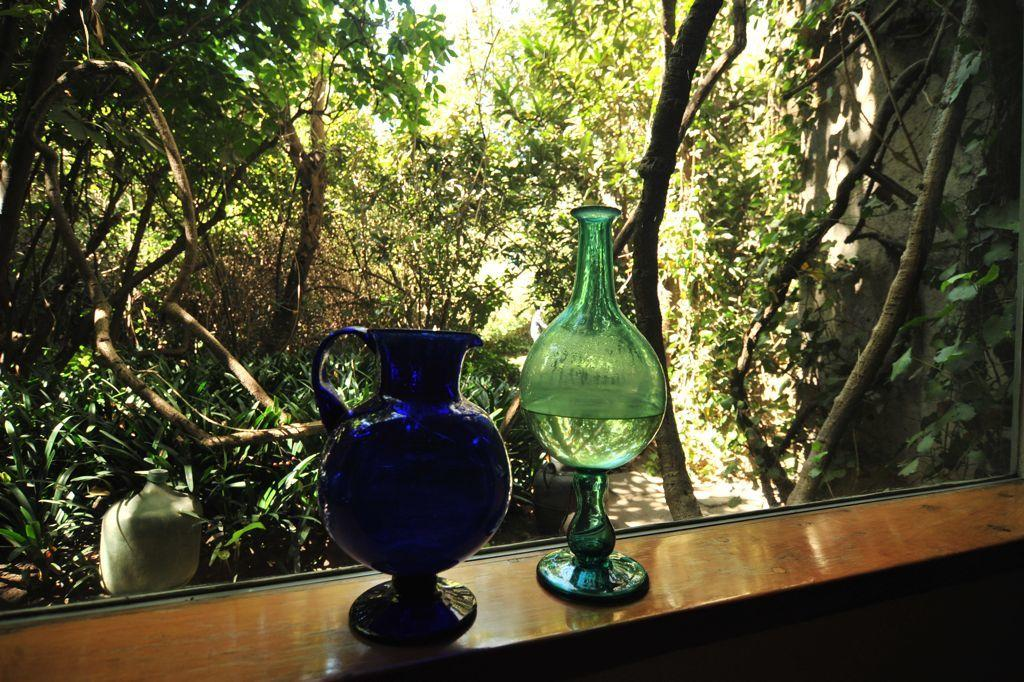What objects are located at the front of the image? There are pots in the front of the image. What type of natural elements can be seen in the background of the image? There are trees in the background of the image. What type of destruction can be seen in the image? There is no destruction present in the image; it features pots in the front and trees in the background. What substance is being used to create the pots in the image? The facts provided do not specify the material used to create the pots, so it cannot be determined from the image. 